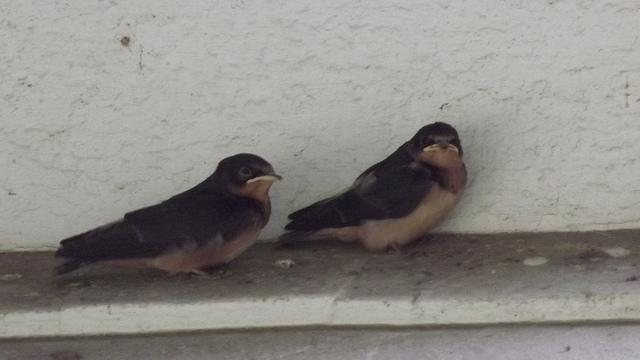How many birds are there?
Write a very short answer. 2. What type of animal's are there?
Quick response, please. Birds. Are the birds related?
Concise answer only. Yes. 